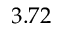Convert formula to latex. <formula><loc_0><loc_0><loc_500><loc_500>3 . 7 2</formula> 